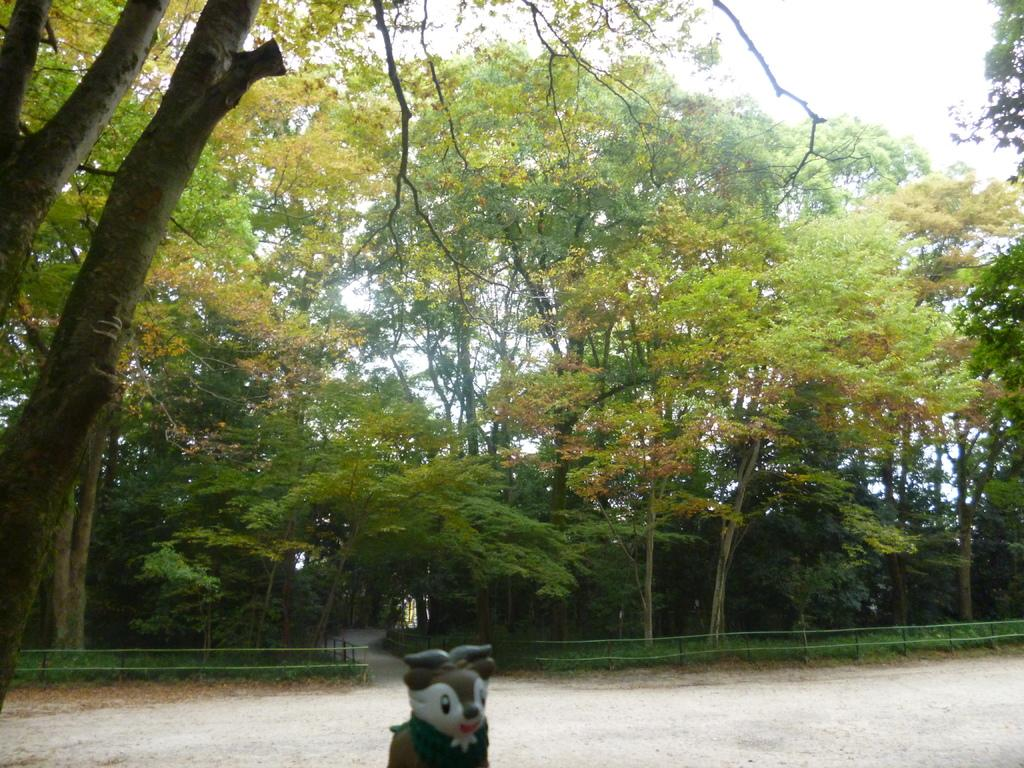What is located at the bottom of the image? There is a doll at the bottom of the image. What can be seen in the center of the image? There are trees in the center of the image. What type of structure is present in the image? There is a fence in the image. What is visible in the background of the image? The sky is visible in the background of the image. What type of powder is being used for the doll's bath in the image? There is no doll's bath or powder present in the image. What color is the lipstick on the doll's lips in the image? There is no lipstick or doll's lips present in the image. 